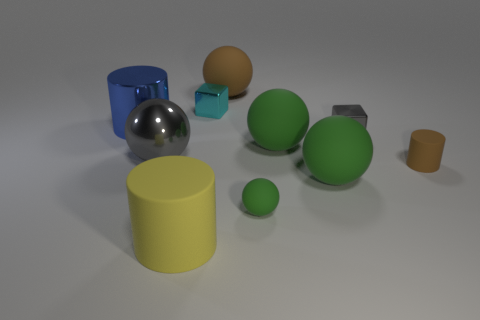There is a tiny block that is the same color as the metallic sphere; what is it made of?
Keep it short and to the point. Metal. What is the material of the yellow cylinder that is the same size as the blue metal object?
Your answer should be very brief. Rubber. What number of things are shiny objects left of the cyan block or rubber things in front of the small gray metallic thing?
Give a very brief answer. 7. What size is the brown cylinder that is made of the same material as the yellow cylinder?
Your answer should be very brief. Small. How many metallic things are gray balls or cubes?
Offer a terse response. 3. What is the size of the cyan block?
Offer a terse response. Small. Is the brown cylinder the same size as the cyan shiny block?
Ensure brevity in your answer.  Yes. There is a big cylinder that is in front of the brown cylinder; what material is it?
Offer a very short reply. Rubber. What material is the brown object that is the same shape as the blue thing?
Your answer should be very brief. Rubber. Are there any metal balls that are on the left side of the large shiny sphere to the left of the tiny gray cube?
Give a very brief answer. No. 